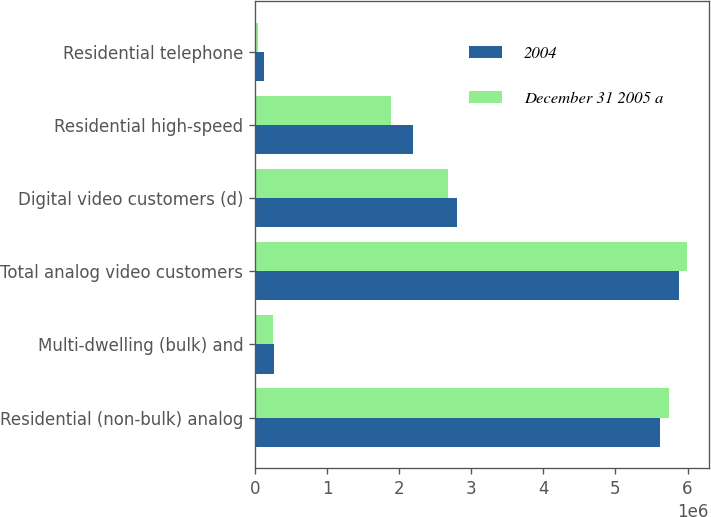Convert chart. <chart><loc_0><loc_0><loc_500><loc_500><stacked_bar_chart><ecel><fcel>Residential (non-bulk) analog<fcel>Multi-dwelling (bulk) and<fcel>Total analog video customers<fcel>Digital video customers (d)<fcel>Residential high-speed<fcel>Residential telephone<nl><fcel>2004<fcel>5.6163e+06<fcel>268200<fcel>5.8845e+06<fcel>2.7966e+06<fcel>2.1964e+06<fcel>121500<nl><fcel>December 31 2005 a<fcel>5.7399e+06<fcel>251600<fcel>5.9915e+06<fcel>2.6747e+06<fcel>1.8844e+06<fcel>45400<nl></chart> 